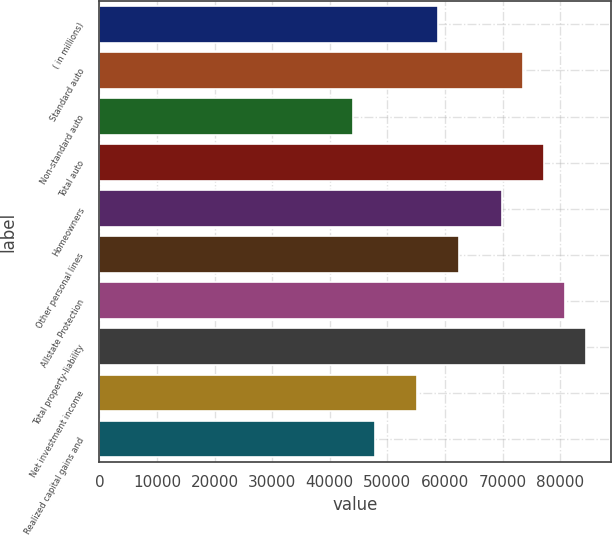Convert chart. <chart><loc_0><loc_0><loc_500><loc_500><bar_chart><fcel>( in millions)<fcel>Standard auto<fcel>Non-standard auto<fcel>Total auto<fcel>Homeowners<fcel>Other personal lines<fcel>Allstate Protection<fcel>Total property-liability<fcel>Net investment income<fcel>Realized capital gains and<nl><fcel>58829.2<fcel>73536<fcel>44122.4<fcel>77212.7<fcel>69859.3<fcel>62505.9<fcel>80889.4<fcel>84566.1<fcel>55152.5<fcel>47799.1<nl></chart> 